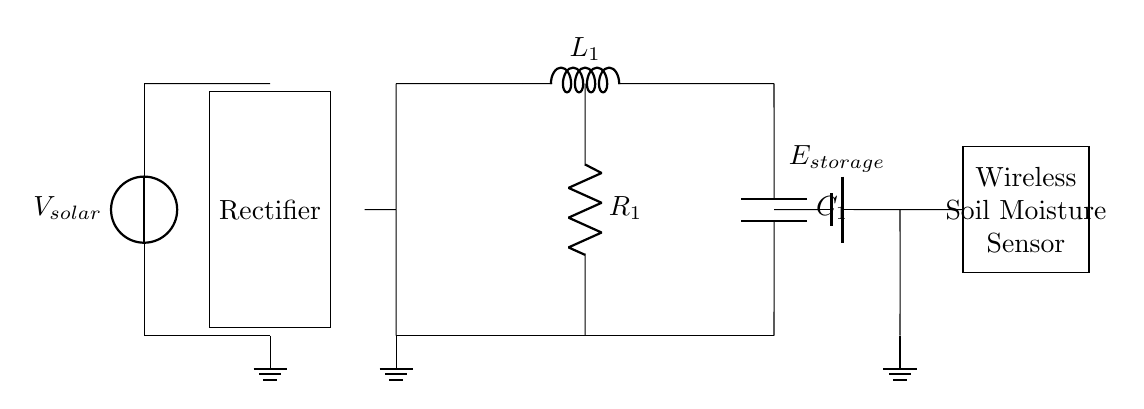What is the power source in this circuit? The power source is the solar panel labeled as V_solar, providing input voltage to the circuit.
Answer: solar panel What component stores energy in this circuit? The circuit includes a battery labeled as E_storage, which is responsible for storing energy generated by the solar panel after rectification.
Answer: battery What are the components that form the energy harvesting circuit? The energy harvesting circuit is made up of an inductor labeled L_1, a capacitor labeled C_1, and a resistor labeled R_1, all connected in series to manage the energy flow.
Answer: inductor, capacitor, resistor What is the role of the rectifier in this circuit? The rectifier converts the alternating current (AC) generated by the solar panel into direct current (DC), making it suitable for charging the energy storage device.
Answer: convert AC to DC How does the inductor L1 function in this energy harvesting circuit? The inductor L1 stores energy in a magnetic field when current flows through it and releases this energy when the current changes, helping to regulate the energy supply to the wireless sensor.
Answer: stores energy What is the purpose of the capacitor C1 in this circuit? The capacitor C1 smoothens the voltage output from the inductor and stores energy temporarily to provide a stable voltage level to the wireless sensor.
Answer: smoothens voltage What will happen if the resistor R1 is removed from the circuit? Removing the resistor R1 would lead to uncontrolled current flow, potentially damaging the circuit components due to excess current and disrupting operation.
Answer: uncontrolled current flow 